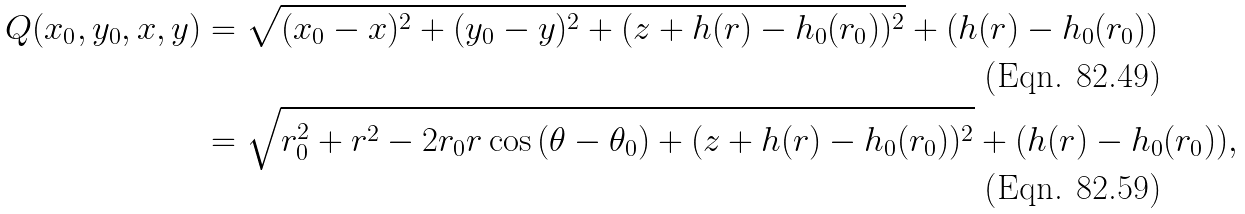<formula> <loc_0><loc_0><loc_500><loc_500>Q ( x _ { 0 } , y _ { 0 } , x , y ) & = \sqrt { ( x _ { 0 } - x ) ^ { 2 } + ( y _ { 0 } - y ) ^ { 2 } + ( z + h ( r ) - h _ { 0 } ( r _ { 0 } ) ) ^ { 2 } } + ( h ( r ) - h _ { 0 } ( r _ { 0 } ) ) \\ & = \sqrt { r _ { 0 } ^ { 2 } + r ^ { 2 } - 2 r _ { 0 } r \cos { ( \theta - \theta _ { 0 } ) } + ( z + h ( r ) - h _ { 0 } ( r _ { 0 } ) ) ^ { 2 } } + ( h ( r ) - h _ { 0 } ( r _ { 0 } ) ) ,</formula> 